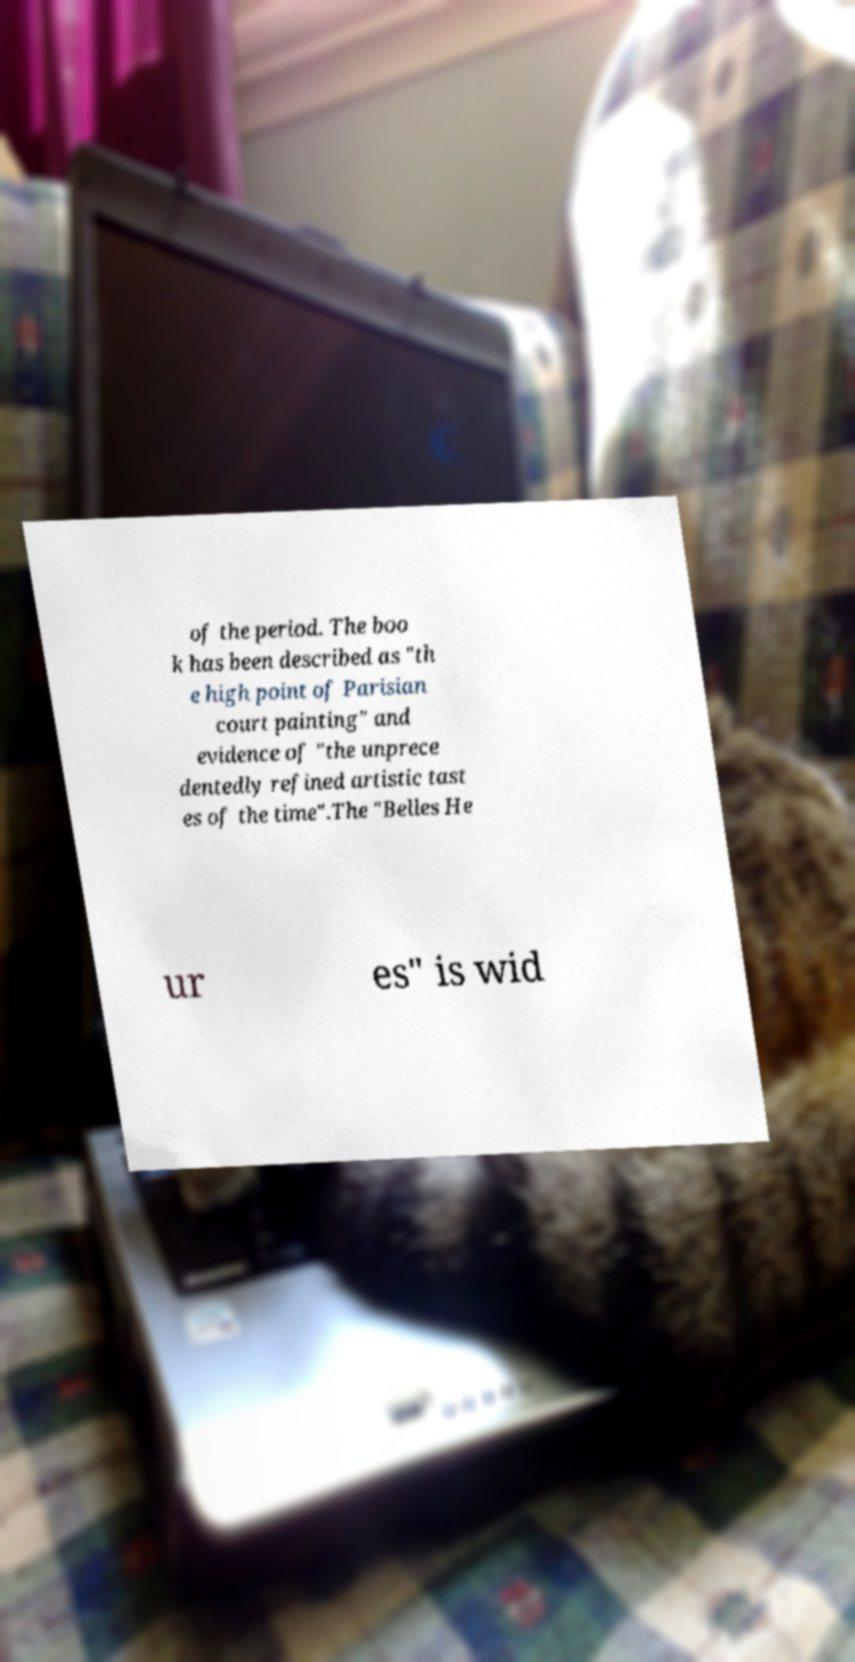Please read and relay the text visible in this image. What does it say? of the period. The boo k has been described as "th e high point of Parisian court painting" and evidence of "the unprece dentedly refined artistic tast es of the time".The "Belles He ur es" is wid 